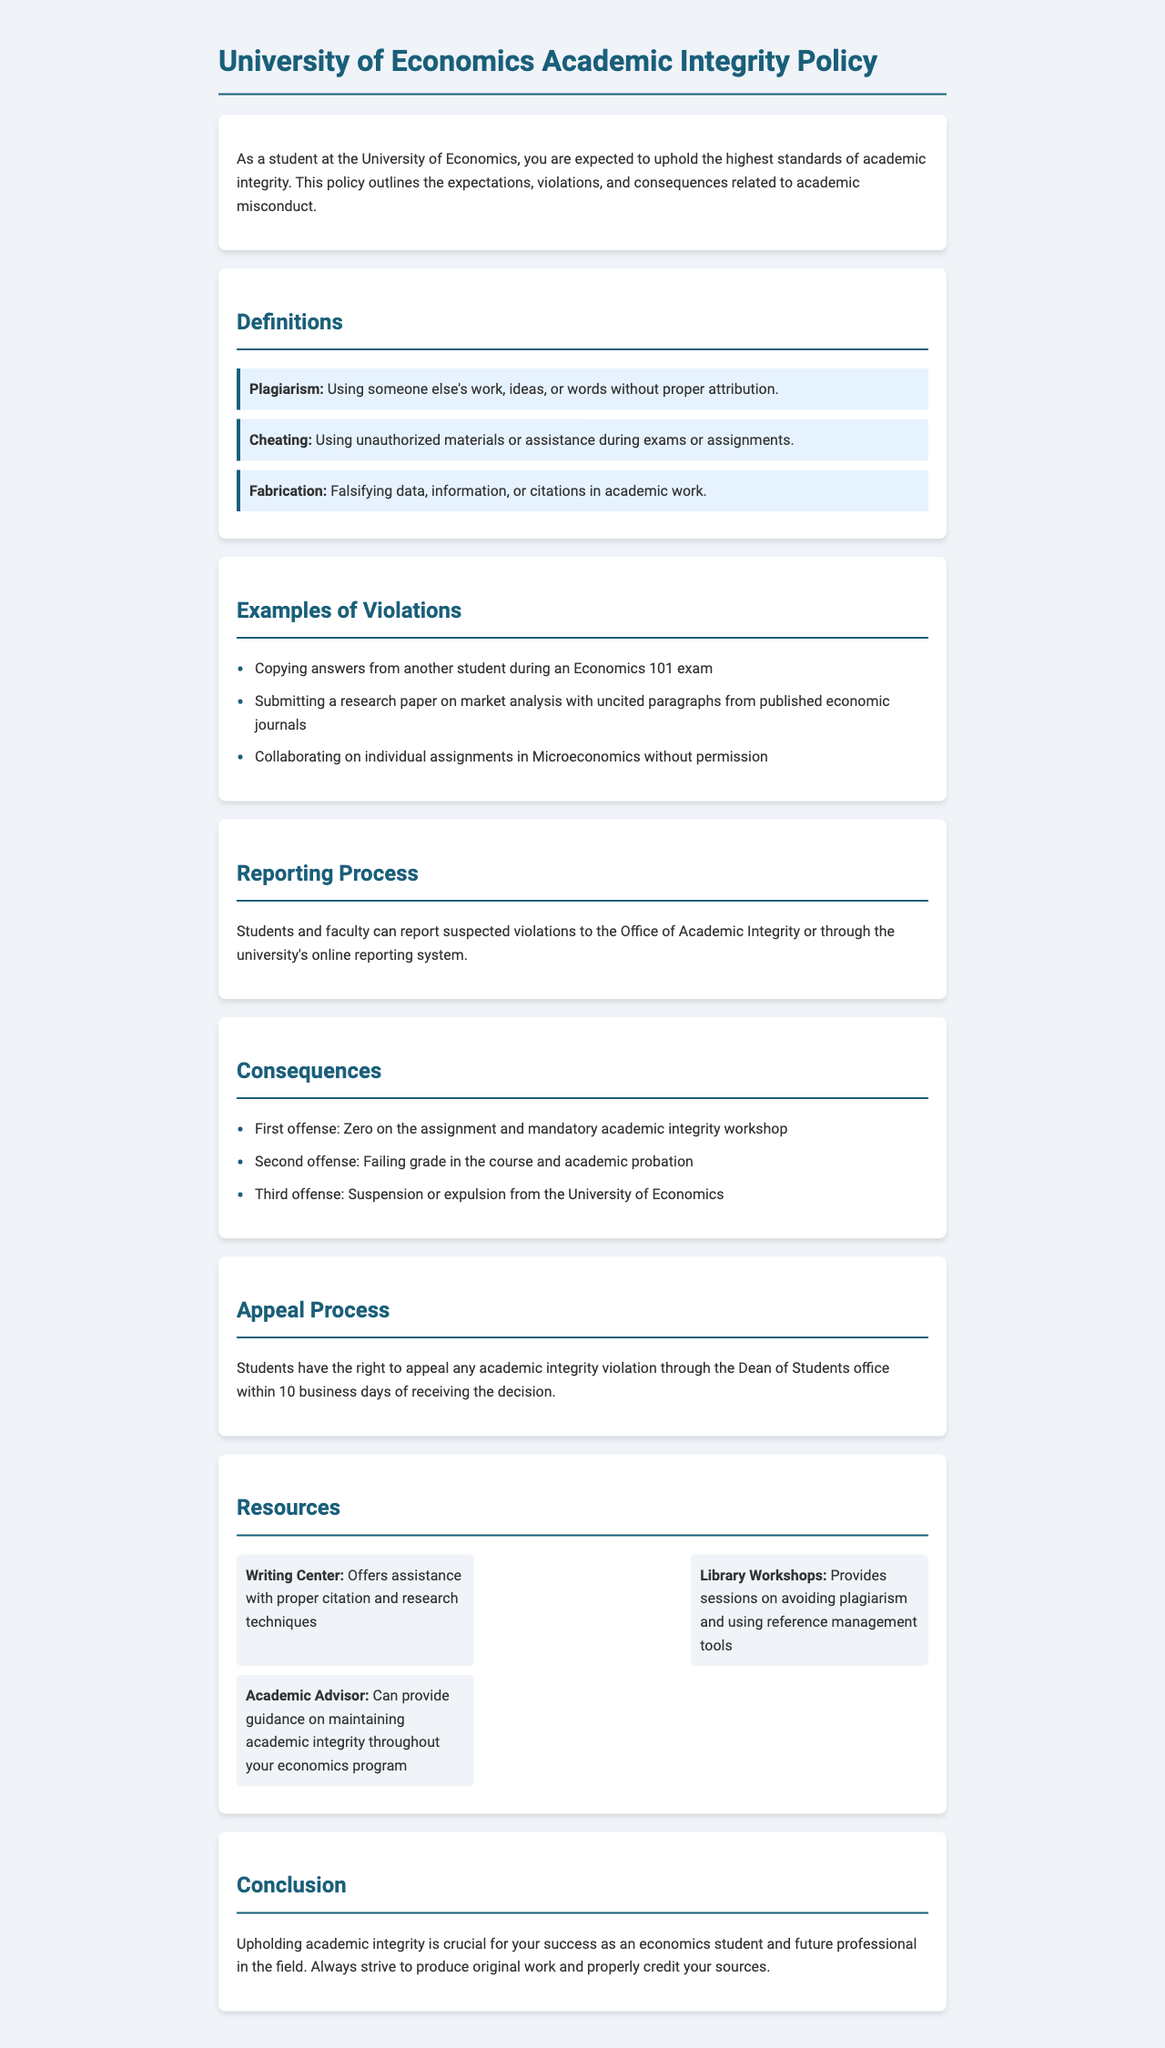What is the definition of plagiarism? Plagiarism is defined in the document as using someone else's work, ideas, or words without proper attribution.
Answer: Using someone else's work, ideas, or words without proper attribution What is the consequence of a second offense? The consequence for a second offense is mentioned in the document, stating that a failing grade in the course and academic probation will be given.
Answer: Failing grade in the course and academic probation What should students do to report suspected violations? The document outlines that students and faculty can report suspected violations to the Office of Academic Integrity or through the university's online reporting system.
Answer: Report to the Office of Academic Integrity or online reporting system How many business days do students have to appeal a violation? The appeal process states that students have the right to appeal within 10 business days of receiving the decision.
Answer: 10 business days What is one resource mentioned for avoiding plagiarism? The document lists resources, specifically mentioning the Library Workshops that provide sessions on avoiding plagiarism.
Answer: Library Workshops 